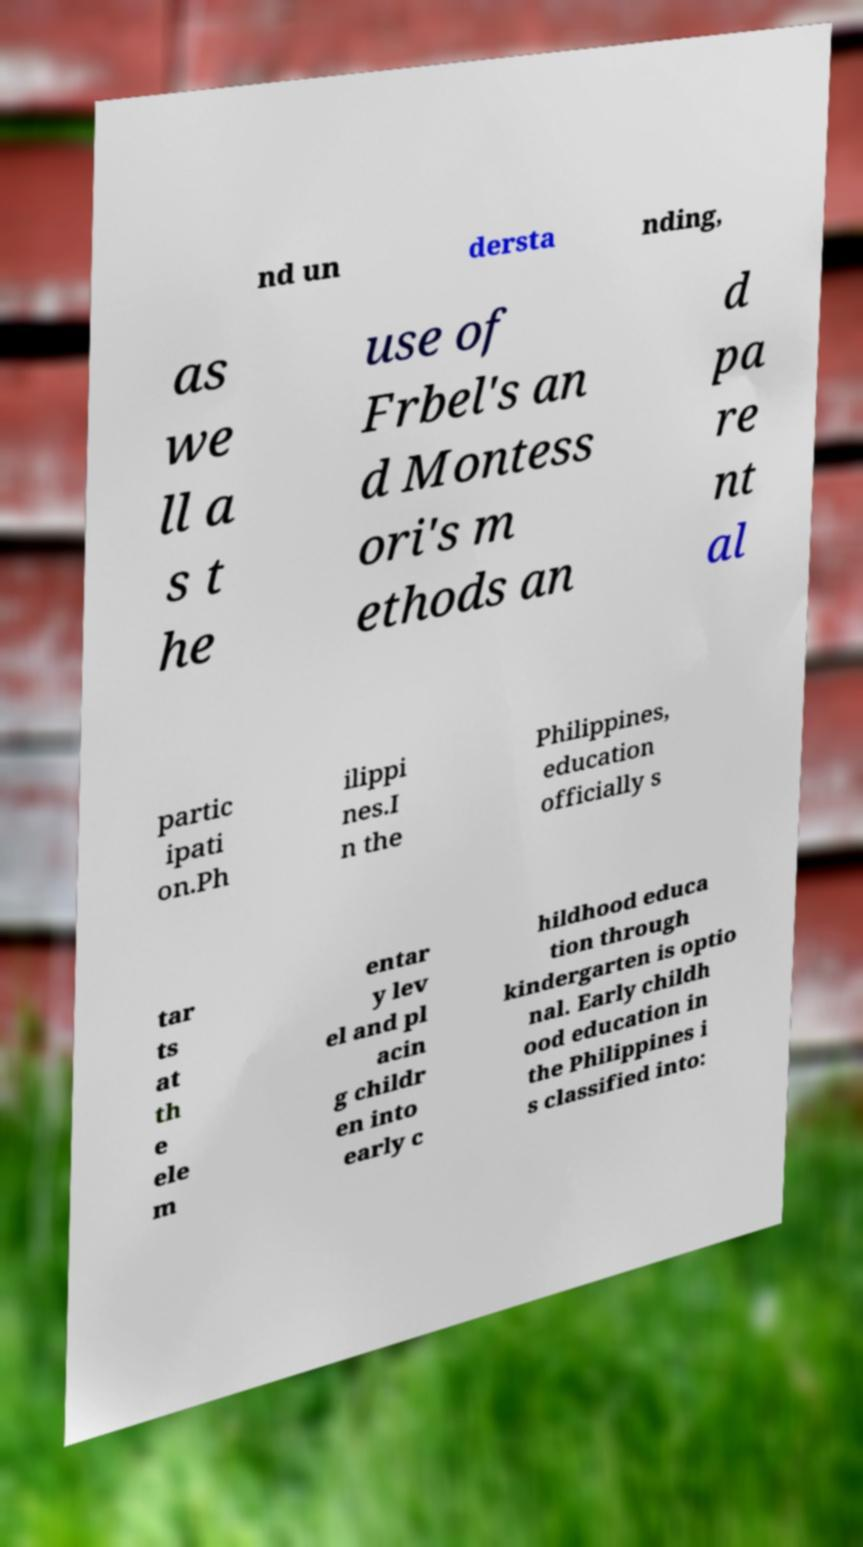For documentation purposes, I need the text within this image transcribed. Could you provide that? nd un dersta nding, as we ll a s t he use of Frbel's an d Montess ori's m ethods an d pa re nt al partic ipati on.Ph ilippi nes.I n the Philippines, education officially s tar ts at th e ele m entar y lev el and pl acin g childr en into early c hildhood educa tion through kindergarten is optio nal. Early childh ood education in the Philippines i s classified into: 